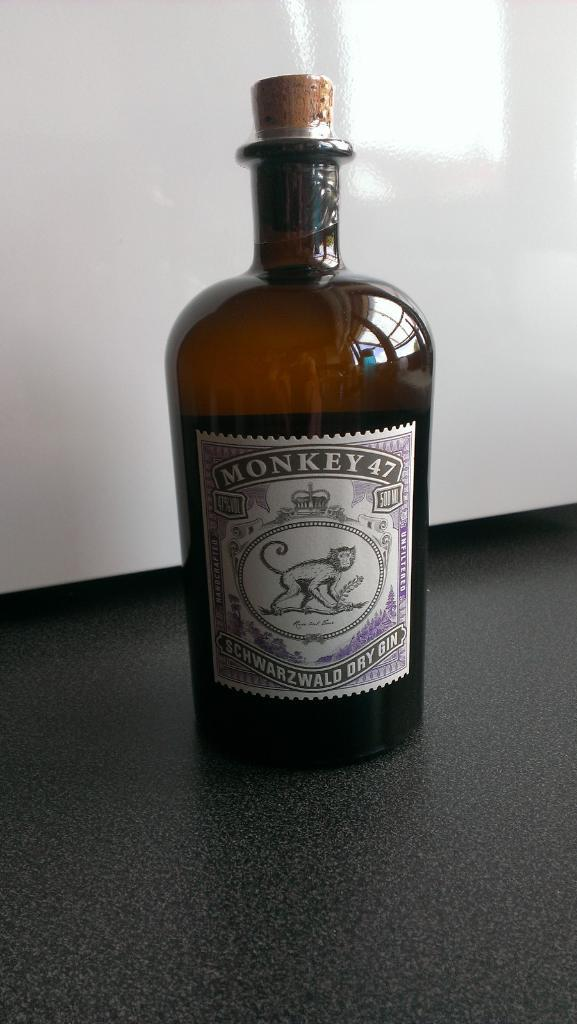<image>
Share a concise interpretation of the image provided. A large flask of Monkey 47 dry gin. 